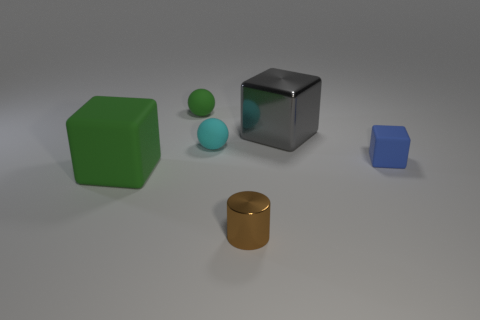The small object that is the same color as the large matte object is what shape?
Offer a terse response. Sphere. What material is the big block behind the object on the left side of the small green matte sphere on the left side of the big metal cube made of?
Give a very brief answer. Metal. What number of metallic things are either small spheres or cyan cylinders?
Ensure brevity in your answer.  0. Do the big matte block and the small cylinder have the same color?
Provide a short and direct response. No. What number of objects are either big brown matte cylinders or gray blocks behind the small cyan ball?
Your answer should be very brief. 1. There is a matte sphere in front of the gray thing; is it the same size as the metal block?
Your answer should be compact. No. How many other things are the same shape as the small brown shiny object?
Make the answer very short. 0. How many brown things are small rubber balls or things?
Offer a very short reply. 1. Do the big block that is on the right side of the big green cube and the large rubber object have the same color?
Give a very brief answer. No. What is the shape of the small blue thing that is made of the same material as the big green cube?
Keep it short and to the point. Cube. 